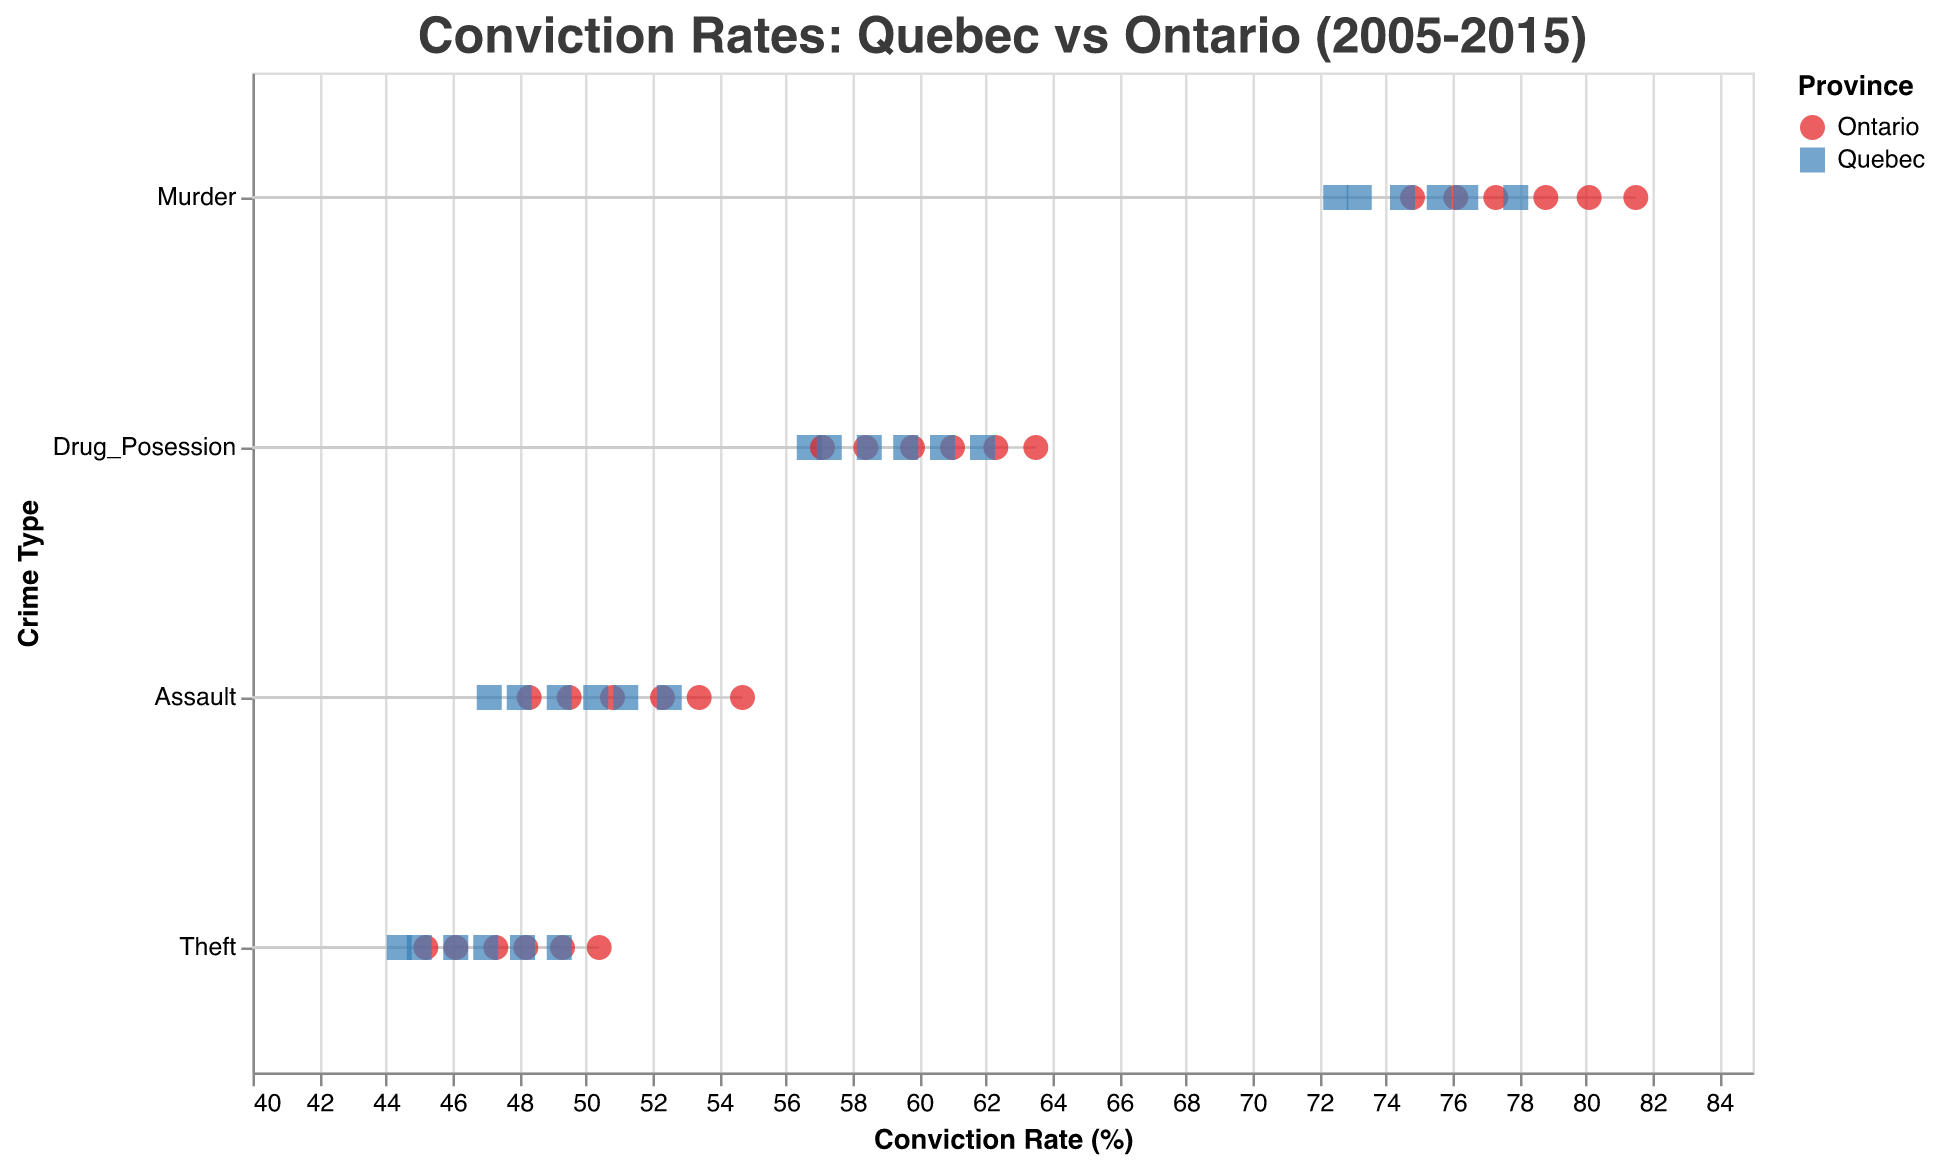What's the title of the figure? The title of the figure is displayed at the top center and reads "Conviction Rates: Quebec vs Ontario (2005-2015)".
Answer: Conviction Rates: Quebec vs Ontario (2005-2015) Which province had a higher conviction rate for murder in 2015? The figure exhibits that Ontario had a murder conviction rate of 81.5%, while Quebec had a rate of 77.9%. Therefore, Ontario had a higher conviction rate for murder in 2015.
Answer: Ontario What is the average conviction rate for assault in Quebec from 2005 to 2015? The conviction rates for assault in Quebec are: 47.1 (2005), 48.0 (2007), 49.2 (2009), 50.3 (2011), 51.2 (2013), and 52.5 (2015). Adding these, the total is 298.3, and dividing by 6 gives the average: 298.3/6 = 49.7%.
Answer: 49.7% Which province had the lowest conviction rate for theft in any given year? From the figure, Quebec had the lowest conviction rate for theft in 2005, with a rate of 44.4%.
Answer: Quebec How did the conviction rates for drug possession in Ontario change from 2005 to 2015? Observing the values for Ontario, the conviction rates for drug possession increased from 57.1% (2005) to 58.4% (2007), 59.8% (2009), 61.0% (2011), 62.3% (2013), and reached 63.5% in 2015, showing a consistent increase.
Answer: Increased In which crime type does the difference in conviction rates between Quebec and Ontario appear to be the smallest on average across the years? By examining the differences in conviction rates for each crime type over the years, the smallest average difference is found in drug possession, where the differences are relatively minor compared to other crime types.
Answer: Drug possession What is the trend in assault conviction rates in Quebec from 2005 to 2015? The trend of assault conviction rates in Quebec can be seen increasing steadily over the years: 47.1% (2005), 48.0% (2007), 49.2% (2009), 50.3% (2011), 51.2% (2013), and 52.5% (2015).
Answer: Increasing Between Quebec and Ontario, which province has generally had higher conviction rates for theft from 2005 to 2015? Referring to the plot, Ontario generally shows higher conviction rates for theft compared to Quebec in all years from 2005 to 2015.
Answer: Ontario Which year shows the largest difference in conviction rates for murder between Quebec and Ontario? In 2015, the plot illustrates the largest difference in conviction rates for murder between Quebec (77.9%) and Ontario (81.5%), resulting in a difference of 3.6%.
Answer: 2015 In 2009, which crime type had a higher conviction rate in Quebec compared to Ontario? Comparing the different crime types in 2009, none of the crime types in Quebec had a higher conviction rate compared to Ontario; Ontario had higher rates in each category.
Answer: None 